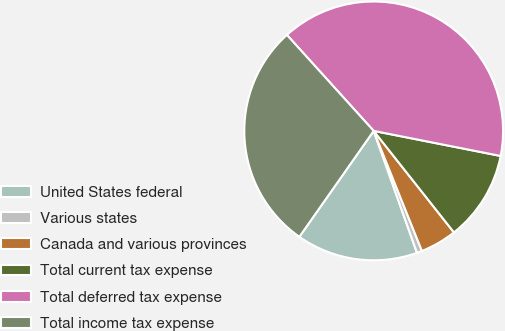Convert chart. <chart><loc_0><loc_0><loc_500><loc_500><pie_chart><fcel>United States federal<fcel>Various states<fcel>Canada and various provinces<fcel>Total current tax expense<fcel>Total deferred tax expense<fcel>Total income tax expense<nl><fcel>15.17%<fcel>0.65%<fcel>4.57%<fcel>11.25%<fcel>39.81%<fcel>28.56%<nl></chart> 